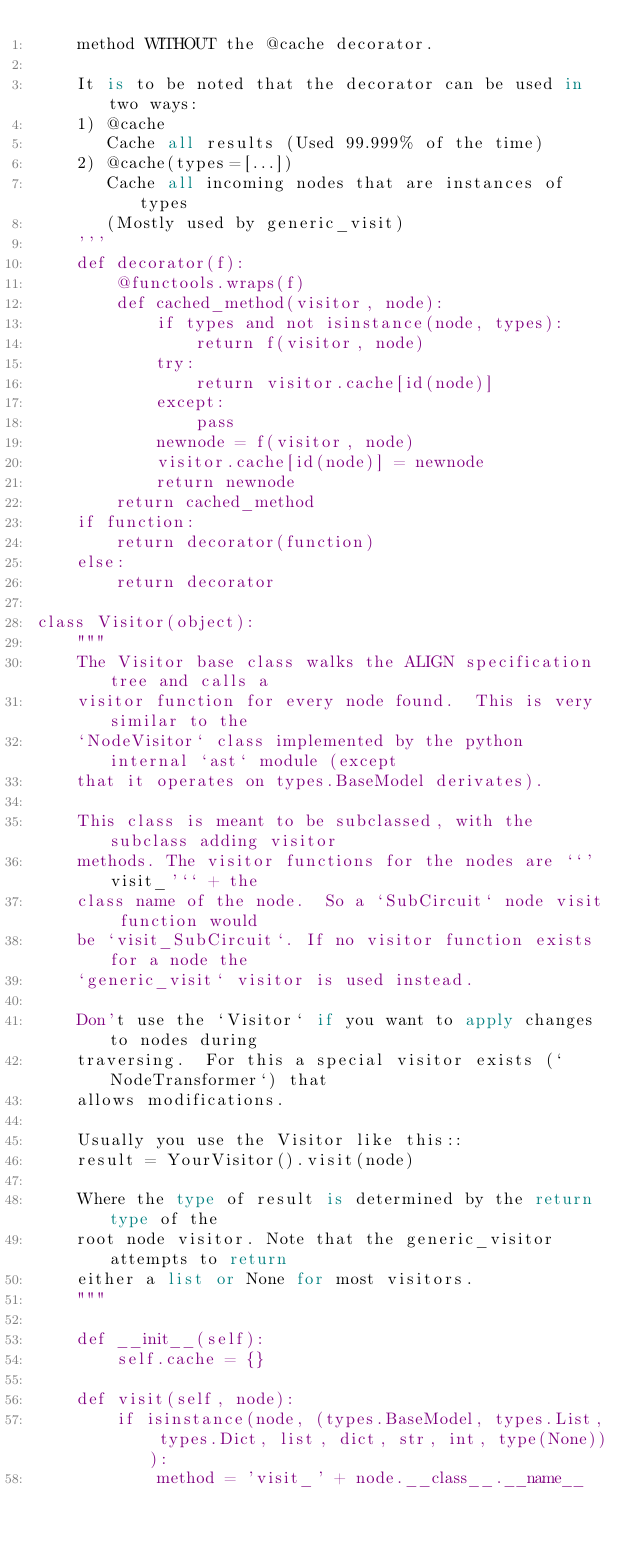Convert code to text. <code><loc_0><loc_0><loc_500><loc_500><_Python_>    method WITHOUT the @cache decorator.

    It is to be noted that the decorator can be used in two ways:
    1) @cache
       Cache all results (Used 99.999% of the time)
    2) @cache(types=[...])
       Cache all incoming nodes that are instances of types
       (Mostly used by generic_visit)
    '''
    def decorator(f):
        @functools.wraps(f)
        def cached_method(visitor, node):
            if types and not isinstance(node, types):
                return f(visitor, node)
            try:
                return visitor.cache[id(node)]
            except:
                pass
            newnode = f(visitor, node)
            visitor.cache[id(node)] = newnode
            return newnode
        return cached_method
    if function:
        return decorator(function)
    else:
        return decorator

class Visitor(object):
    """
    The Visitor base class walks the ALIGN specification tree and calls a
    visitor function for every node found.  This is very similar to the
    `NodeVisitor` class implemented by the python internal `ast` module (except
    that it operates on types.BaseModel derivates).

    This class is meant to be subclassed, with the subclass adding visitor
    methods. The visitor functions for the nodes are ``'visit_'`` + the
    class name of the node.  So a `SubCircuit` node visit function would
    be `visit_SubCircuit`. If no visitor function exists for a node the
    `generic_visit` visitor is used instead.

    Don't use the `Visitor` if you want to apply changes to nodes during
    traversing.  For this a special visitor exists (`NodeTransformer`) that
    allows modifications.

    Usually you use the Visitor like this::
    result = YourVisitor().visit(node)

    Where the type of result is determined by the return type of the
    root node visitor. Note that the generic_visitor attempts to return
    either a list or None for most visitors.
    """

    def __init__(self):
        self.cache = {}

    def visit(self, node):
        if isinstance(node, (types.BaseModel, types.List, types.Dict, list, dict, str, int, type(None))):
            method = 'visit_' + node.__class__.__name__</code> 